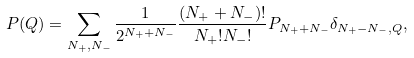Convert formula to latex. <formula><loc_0><loc_0><loc_500><loc_500>P ( Q ) = \sum _ { N _ { + } , N _ { - } } \frac { 1 } { 2 ^ { N _ { + } + N _ { - } } } \frac { ( N _ { + } + N _ { - } ) ! } { N _ { + } ! N _ { - } ! } P _ { N _ { + } + N _ { - } } \delta _ { N _ { + } - N _ { - } , Q } ,</formula> 